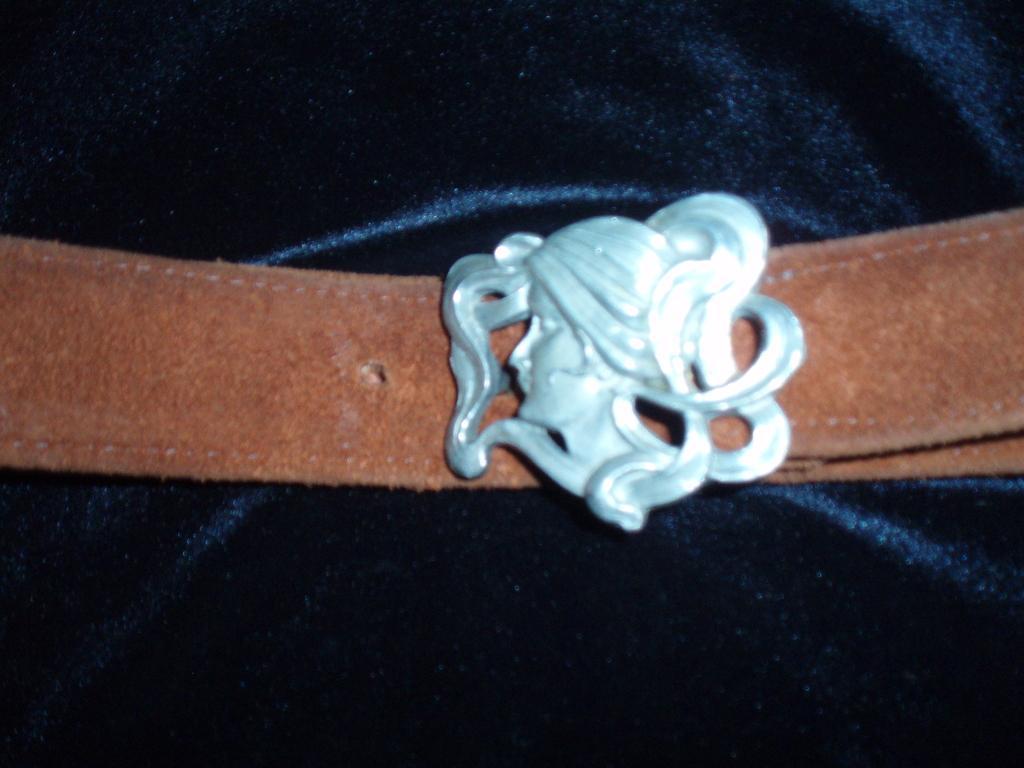Please provide a concise description of this image. This looks like a belt with a buckle attached to it. I think this is a cloth. 